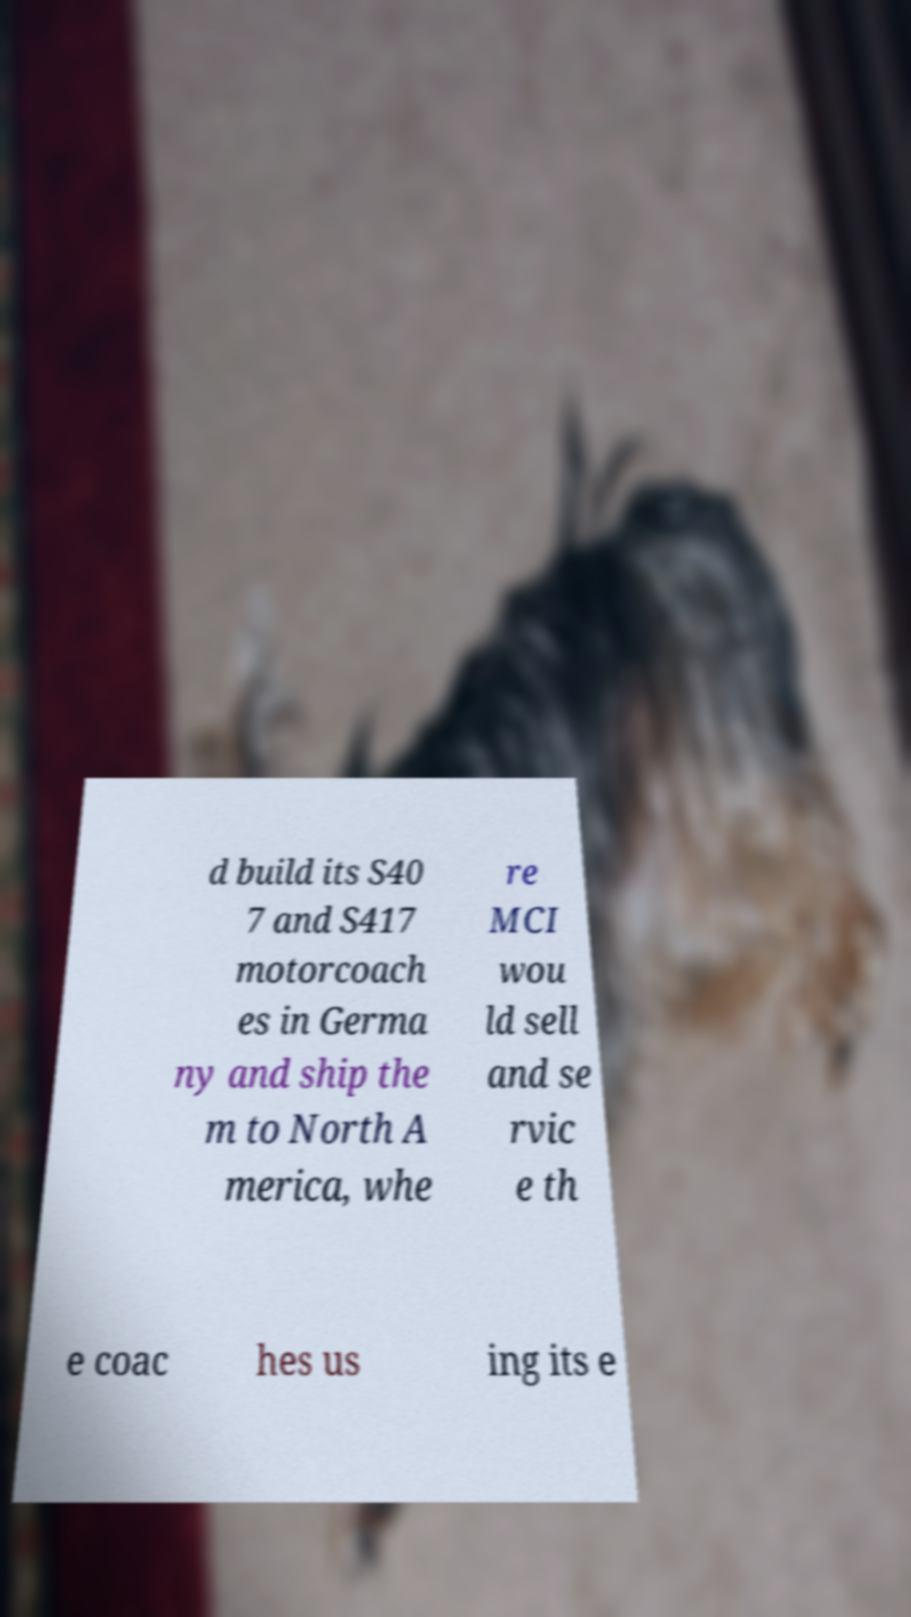Could you extract and type out the text from this image? d build its S40 7 and S417 motorcoach es in Germa ny and ship the m to North A merica, whe re MCI wou ld sell and se rvic e th e coac hes us ing its e 